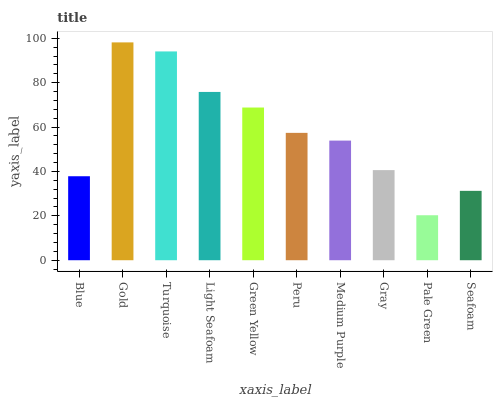Is Pale Green the minimum?
Answer yes or no. Yes. Is Gold the maximum?
Answer yes or no. Yes. Is Turquoise the minimum?
Answer yes or no. No. Is Turquoise the maximum?
Answer yes or no. No. Is Gold greater than Turquoise?
Answer yes or no. Yes. Is Turquoise less than Gold?
Answer yes or no. Yes. Is Turquoise greater than Gold?
Answer yes or no. No. Is Gold less than Turquoise?
Answer yes or no. No. Is Peru the high median?
Answer yes or no. Yes. Is Medium Purple the low median?
Answer yes or no. Yes. Is Gold the high median?
Answer yes or no. No. Is Light Seafoam the low median?
Answer yes or no. No. 